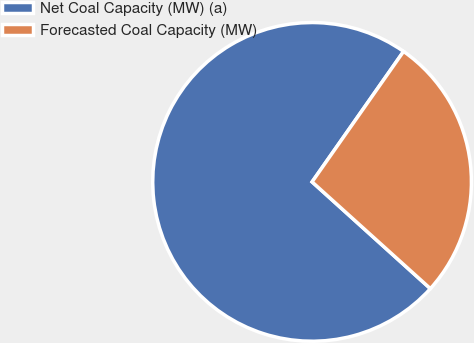Convert chart to OTSL. <chart><loc_0><loc_0><loc_500><loc_500><pie_chart><fcel>Net Coal Capacity (MW) (a)<fcel>Forecasted Coal Capacity (MW)<nl><fcel>73.05%<fcel>26.95%<nl></chart> 